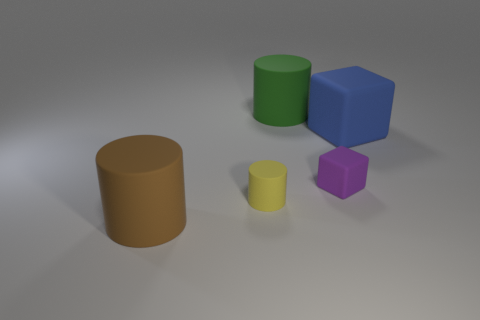How many objects are there in total, and what are their colors? There are five objects in the image. Starting from the left, there is a brown cylinder, a green cylinder, a blue cube, a yellow smaller cylinder, and a purple cube. 